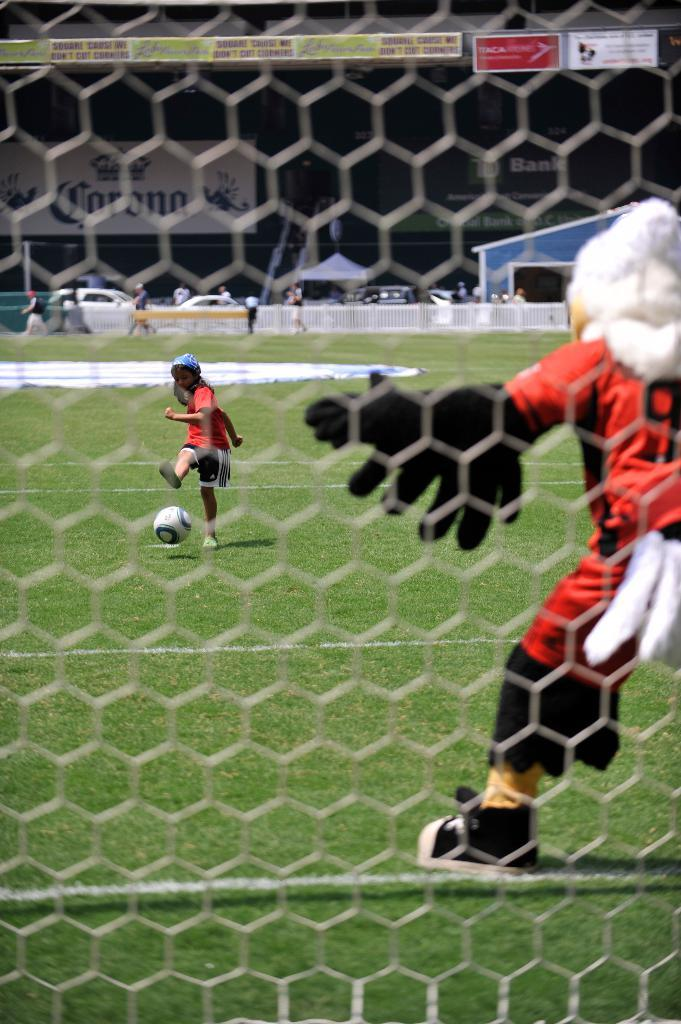What is the main structure visible in the image? There is a fence in the image. What activity is taking place behind the fence? People are playing ball behind the fence. Can you describe any other structures or buildings in the image? There is a building visible in the image. How many people are sleeping in the image? There is no indication of anyone sleeping in the image. What type of power source is being used by the people playing ball? There is no information about a power source in the image, as it features people playing ball behind a fence and a building in the background. 